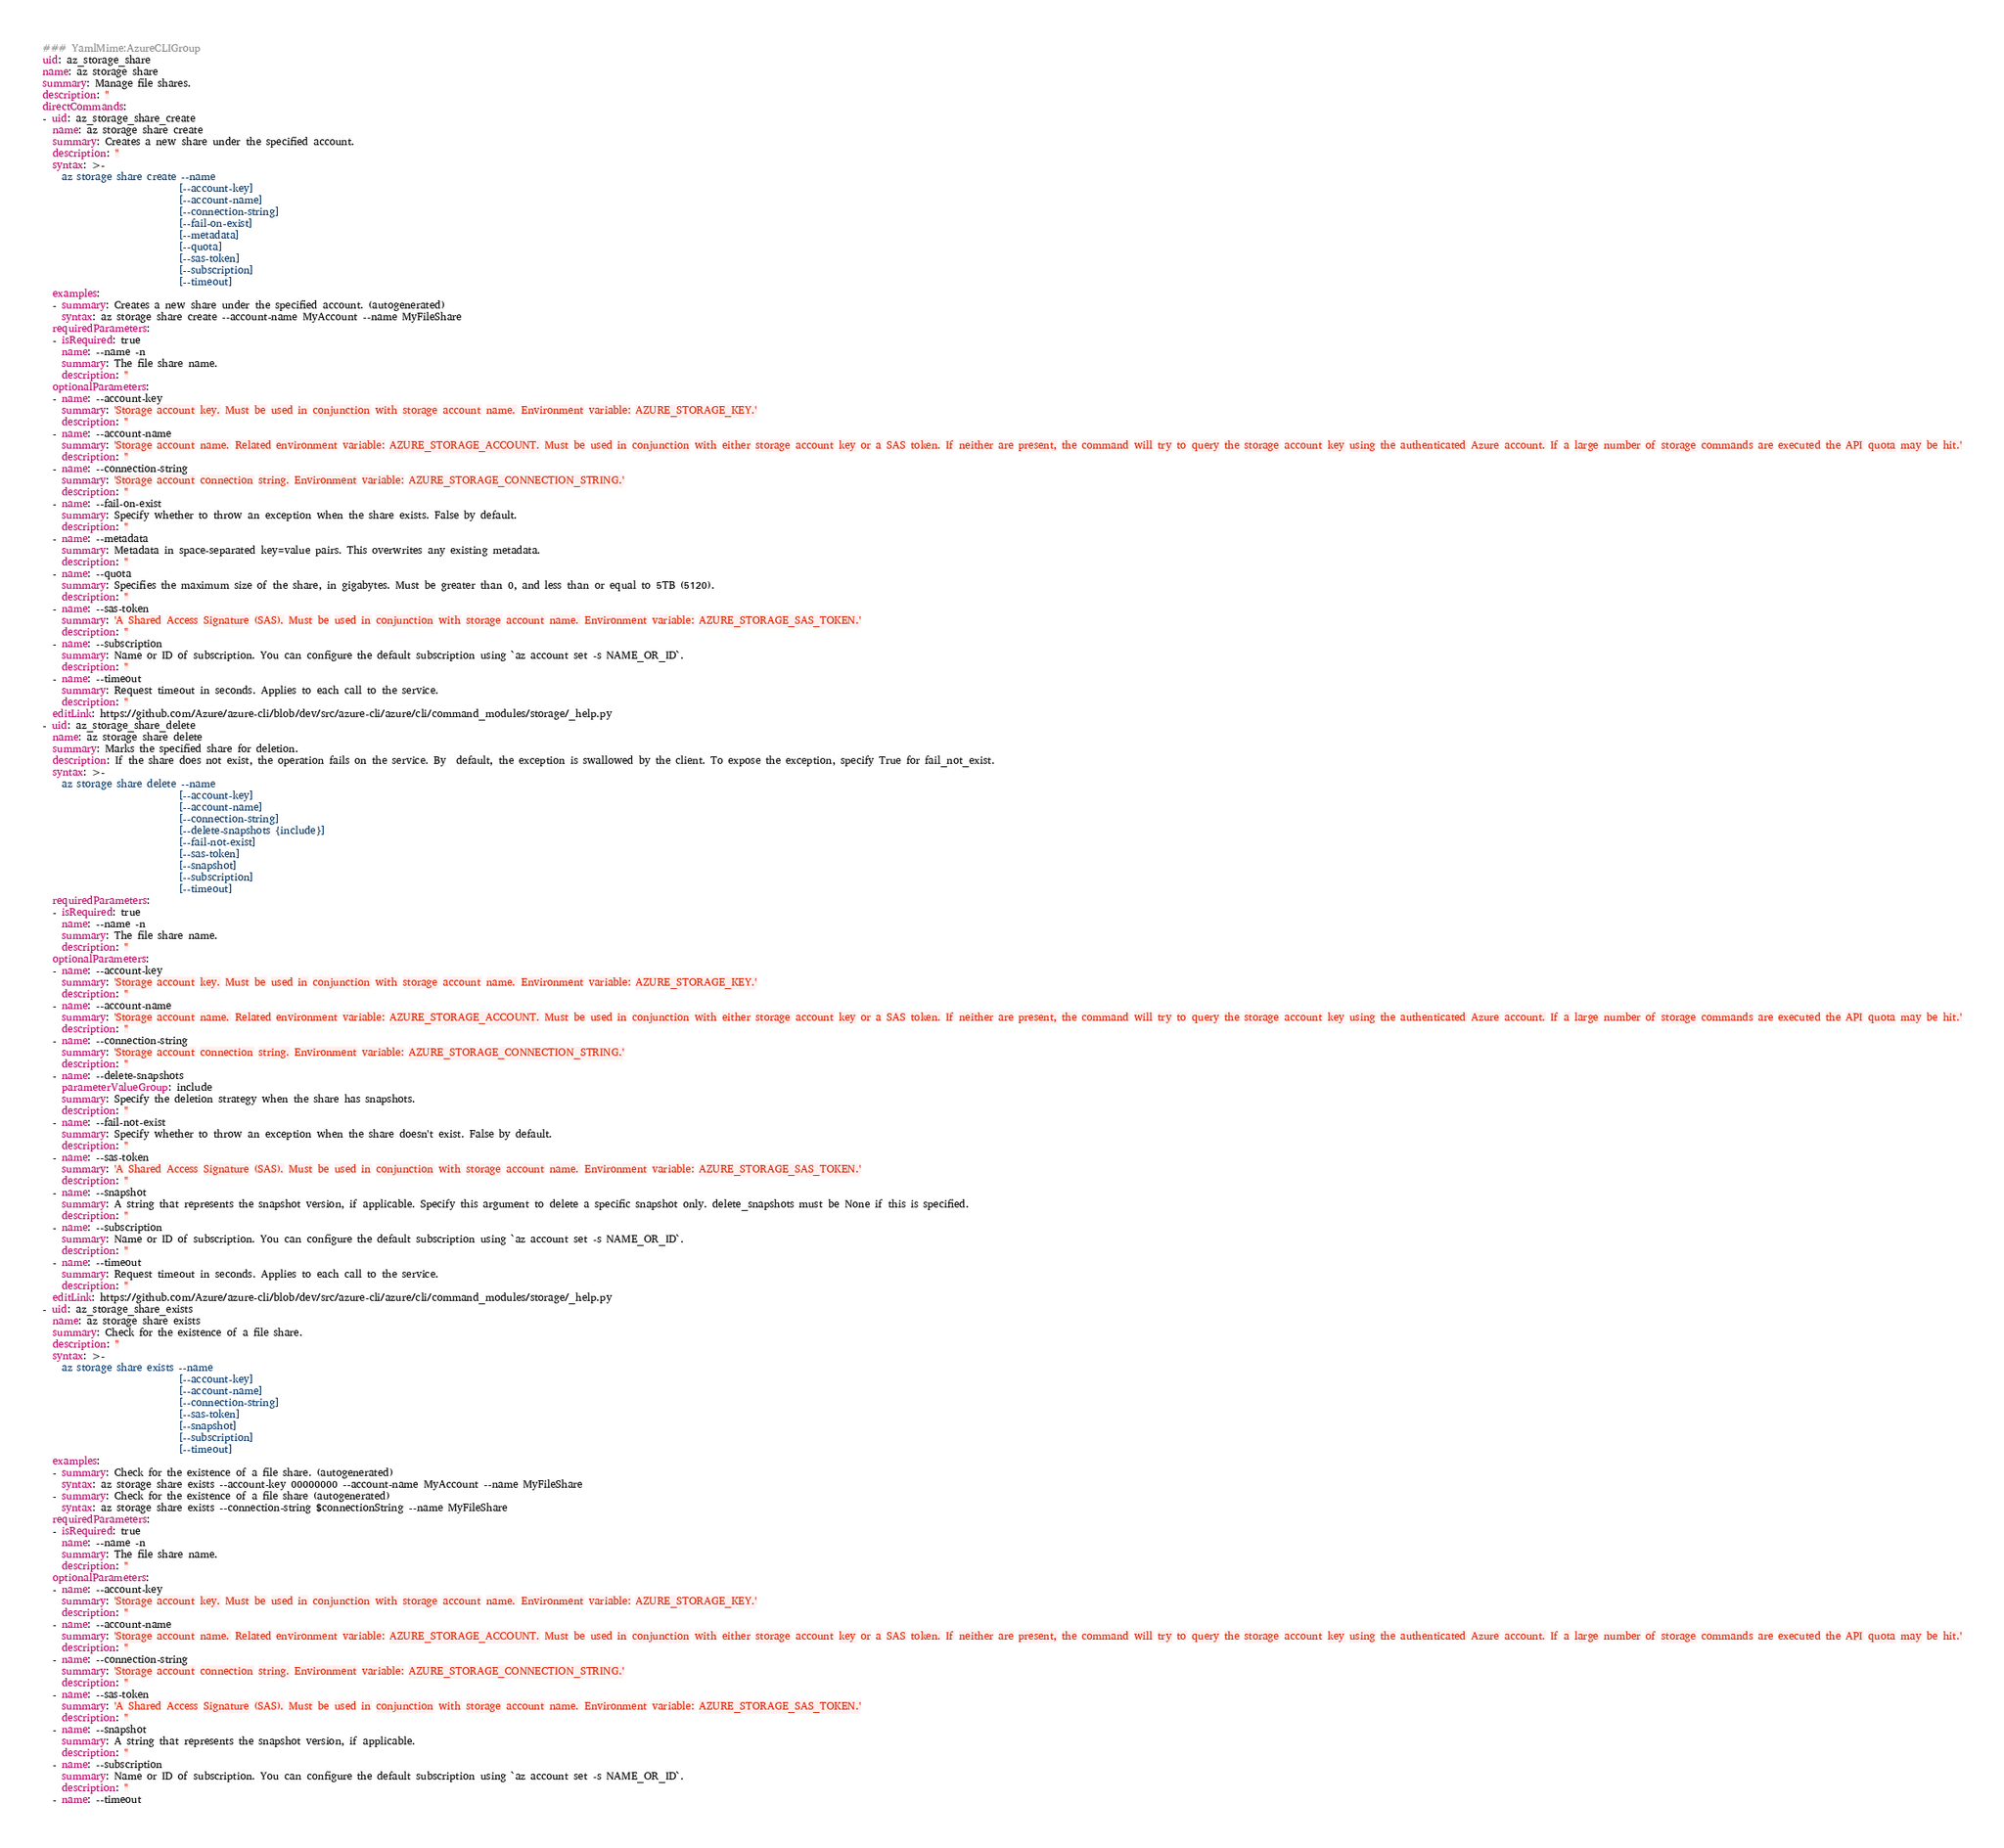<code> <loc_0><loc_0><loc_500><loc_500><_YAML_>### YamlMime:AzureCLIGroup
uid: az_storage_share
name: az storage share
summary: Manage file shares.
description: ''
directCommands:
- uid: az_storage_share_create
  name: az storage share create
  summary: Creates a new share under the specified account.
  description: ''
  syntax: >-
    az storage share create --name
                            [--account-key]
                            [--account-name]
                            [--connection-string]
                            [--fail-on-exist]
                            [--metadata]
                            [--quota]
                            [--sas-token]
                            [--subscription]
                            [--timeout]
  examples:
  - summary: Creates a new share under the specified account. (autogenerated)
    syntax: az storage share create --account-name MyAccount --name MyFileShare
  requiredParameters:
  - isRequired: true
    name: --name -n
    summary: The file share name.
    description: ''
  optionalParameters:
  - name: --account-key
    summary: 'Storage account key. Must be used in conjunction with storage account name. Environment variable: AZURE_STORAGE_KEY.'
    description: ''
  - name: --account-name
    summary: 'Storage account name. Related environment variable: AZURE_STORAGE_ACCOUNT. Must be used in conjunction with either storage account key or a SAS token. If neither are present, the command will try to query the storage account key using the authenticated Azure account. If a large number of storage commands are executed the API quota may be hit.'
    description: ''
  - name: --connection-string
    summary: 'Storage account connection string. Environment variable: AZURE_STORAGE_CONNECTION_STRING.'
    description: ''
  - name: --fail-on-exist
    summary: Specify whether to throw an exception when the share exists. False by default.
    description: ''
  - name: --metadata
    summary: Metadata in space-separated key=value pairs. This overwrites any existing metadata.
    description: ''
  - name: --quota
    summary: Specifies the maximum size of the share, in gigabytes. Must be greater than 0, and less than or equal to 5TB (5120).
    description: ''
  - name: --sas-token
    summary: 'A Shared Access Signature (SAS). Must be used in conjunction with storage account name. Environment variable: AZURE_STORAGE_SAS_TOKEN.'
    description: ''
  - name: --subscription
    summary: Name or ID of subscription. You can configure the default subscription using `az account set -s NAME_OR_ID`.
    description: ''
  - name: --timeout
    summary: Request timeout in seconds. Applies to each call to the service.
    description: ''
  editLink: https://github.com/Azure/azure-cli/blob/dev/src/azure-cli/azure/cli/command_modules/storage/_help.py
- uid: az_storage_share_delete
  name: az storage share delete
  summary: Marks the specified share for deletion.
  description: If the share does not exist, the operation fails on the service. By  default, the exception is swallowed by the client. To expose the exception, specify True for fail_not_exist.
  syntax: >-
    az storage share delete --name
                            [--account-key]
                            [--account-name]
                            [--connection-string]
                            [--delete-snapshots {include}]
                            [--fail-not-exist]
                            [--sas-token]
                            [--snapshot]
                            [--subscription]
                            [--timeout]
  requiredParameters:
  - isRequired: true
    name: --name -n
    summary: The file share name.
    description: ''
  optionalParameters:
  - name: --account-key
    summary: 'Storage account key. Must be used in conjunction with storage account name. Environment variable: AZURE_STORAGE_KEY.'
    description: ''
  - name: --account-name
    summary: 'Storage account name. Related environment variable: AZURE_STORAGE_ACCOUNT. Must be used in conjunction with either storage account key or a SAS token. If neither are present, the command will try to query the storage account key using the authenticated Azure account. If a large number of storage commands are executed the API quota may be hit.'
    description: ''
  - name: --connection-string
    summary: 'Storage account connection string. Environment variable: AZURE_STORAGE_CONNECTION_STRING.'
    description: ''
  - name: --delete-snapshots
    parameterValueGroup: include
    summary: Specify the deletion strategy when the share has snapshots.
    description: ''
  - name: --fail-not-exist
    summary: Specify whether to throw an exception when the share doesn't exist. False by default.
    description: ''
  - name: --sas-token
    summary: 'A Shared Access Signature (SAS). Must be used in conjunction with storage account name. Environment variable: AZURE_STORAGE_SAS_TOKEN.'
    description: ''
  - name: --snapshot
    summary: A string that represents the snapshot version, if applicable. Specify this argument to delete a specific snapshot only. delete_snapshots must be None if this is specified.
    description: ''
  - name: --subscription
    summary: Name or ID of subscription. You can configure the default subscription using `az account set -s NAME_OR_ID`.
    description: ''
  - name: --timeout
    summary: Request timeout in seconds. Applies to each call to the service.
    description: ''
  editLink: https://github.com/Azure/azure-cli/blob/dev/src/azure-cli/azure/cli/command_modules/storage/_help.py
- uid: az_storage_share_exists
  name: az storage share exists
  summary: Check for the existence of a file share.
  description: ''
  syntax: >-
    az storage share exists --name
                            [--account-key]
                            [--account-name]
                            [--connection-string]
                            [--sas-token]
                            [--snapshot]
                            [--subscription]
                            [--timeout]
  examples:
  - summary: Check for the existence of a file share. (autogenerated)
    syntax: az storage share exists --account-key 00000000 --account-name MyAccount --name MyFileShare
  - summary: Check for the existence of a file share (autogenerated)
    syntax: az storage share exists --connection-string $connectionString --name MyFileShare
  requiredParameters:
  - isRequired: true
    name: --name -n
    summary: The file share name.
    description: ''
  optionalParameters:
  - name: --account-key
    summary: 'Storage account key. Must be used in conjunction with storage account name. Environment variable: AZURE_STORAGE_KEY.'
    description: ''
  - name: --account-name
    summary: 'Storage account name. Related environment variable: AZURE_STORAGE_ACCOUNT. Must be used in conjunction with either storage account key or a SAS token. If neither are present, the command will try to query the storage account key using the authenticated Azure account. If a large number of storage commands are executed the API quota may be hit.'
    description: ''
  - name: --connection-string
    summary: 'Storage account connection string. Environment variable: AZURE_STORAGE_CONNECTION_STRING.'
    description: ''
  - name: --sas-token
    summary: 'A Shared Access Signature (SAS). Must be used in conjunction with storage account name. Environment variable: AZURE_STORAGE_SAS_TOKEN.'
    description: ''
  - name: --snapshot
    summary: A string that represents the snapshot version, if applicable.
    description: ''
  - name: --subscription
    summary: Name or ID of subscription. You can configure the default subscription using `az account set -s NAME_OR_ID`.
    description: ''
  - name: --timeout</code> 